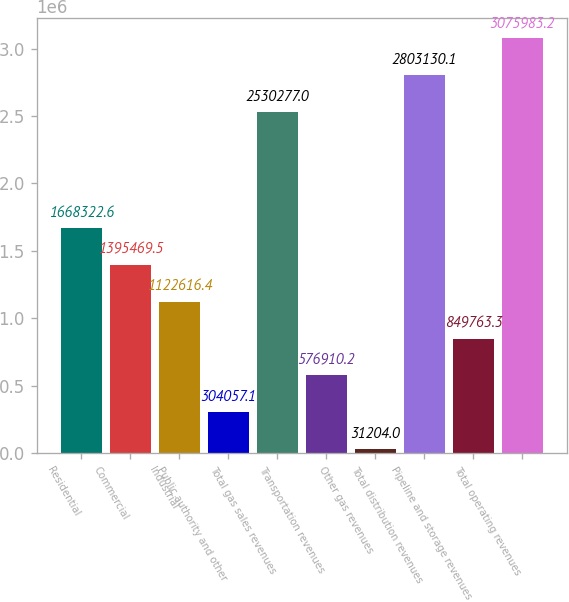Convert chart. <chart><loc_0><loc_0><loc_500><loc_500><bar_chart><fcel>Residential<fcel>Commercial<fcel>Industrial<fcel>Public authority and other<fcel>Total gas sales revenues<fcel>Transportation revenues<fcel>Other gas revenues<fcel>Total distribution revenues<fcel>Pipeline and storage revenues<fcel>Total operating revenues<nl><fcel>1.66832e+06<fcel>1.39547e+06<fcel>1.12262e+06<fcel>304057<fcel>2.53028e+06<fcel>576910<fcel>31204<fcel>2.80313e+06<fcel>849763<fcel>3.07598e+06<nl></chart> 